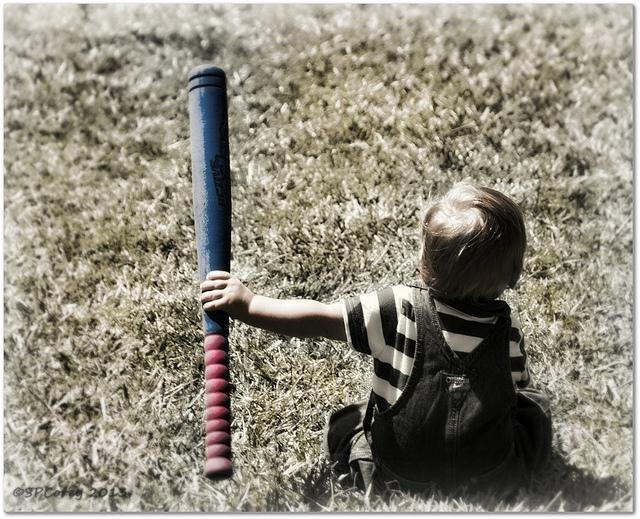How many chairs are there?
Give a very brief answer. 0. 